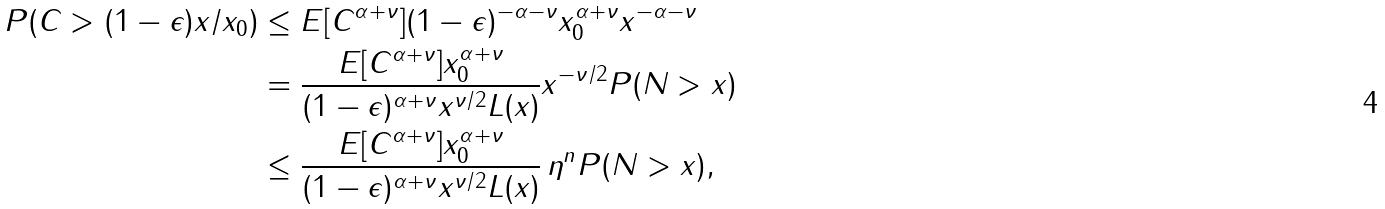<formula> <loc_0><loc_0><loc_500><loc_500>P ( C > ( 1 - \epsilon ) x / x _ { 0 } ) & \leq E [ C ^ { \alpha + \nu } ] ( 1 - \epsilon ) ^ { - \alpha - \nu } x _ { 0 } ^ { \alpha + \nu } x ^ { - \alpha - \nu } \\ & = \frac { E [ C ^ { \alpha + \nu } ] x _ { 0 } ^ { \alpha + \nu } } { ( 1 - \epsilon ) ^ { \alpha + \nu } x ^ { \nu / 2 } L ( x ) } x ^ { - \nu / 2 } P ( N > x ) \\ & \leq \frac { E [ C ^ { \alpha + \nu } ] x _ { 0 } ^ { \alpha + \nu } } { ( 1 - \epsilon ) ^ { \alpha + \nu } x ^ { \nu / 2 } L ( x ) } \, \eta ^ { n } P ( N > x ) ,</formula> 